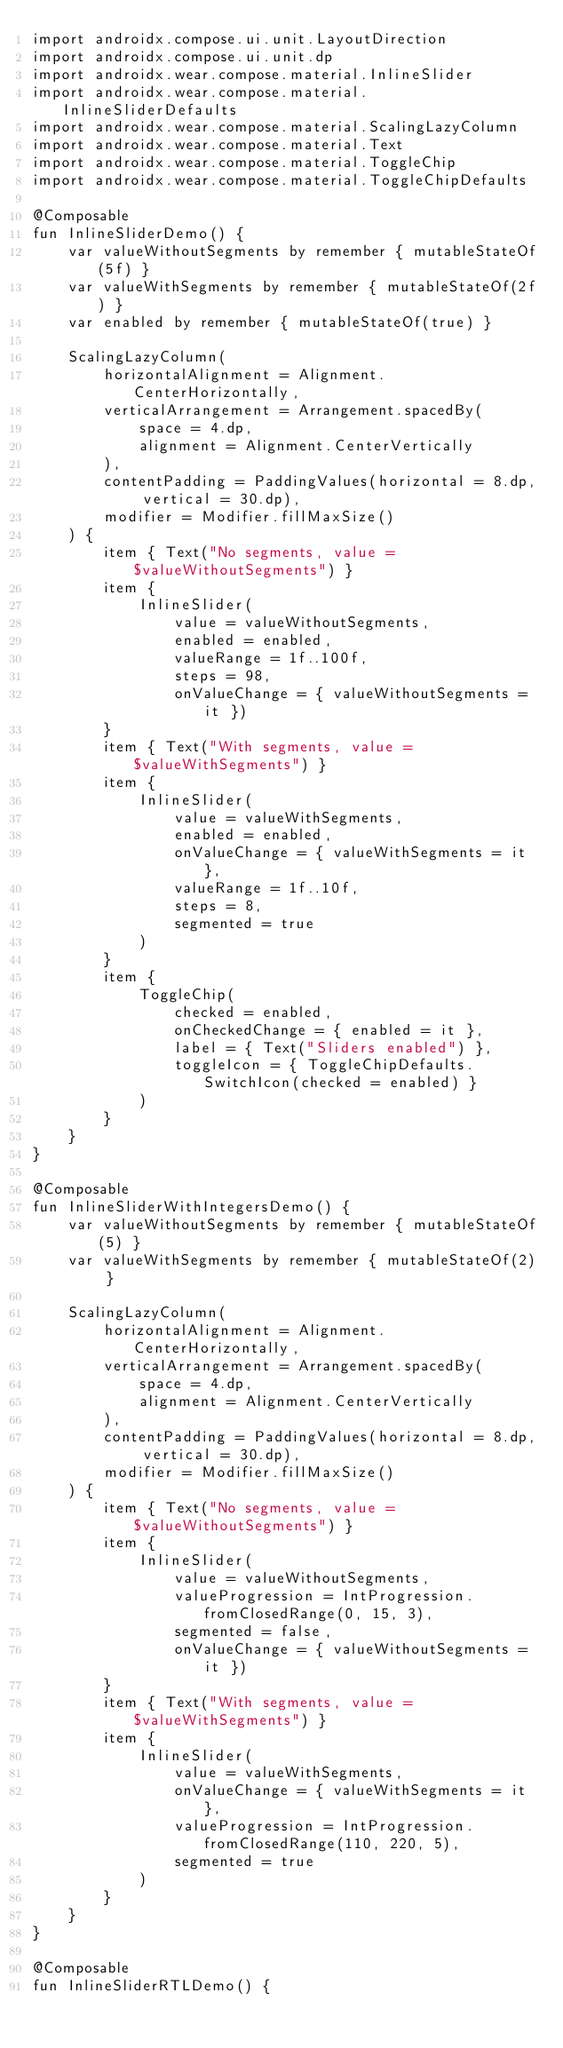Convert code to text. <code><loc_0><loc_0><loc_500><loc_500><_Kotlin_>import androidx.compose.ui.unit.LayoutDirection
import androidx.compose.ui.unit.dp
import androidx.wear.compose.material.InlineSlider
import androidx.wear.compose.material.InlineSliderDefaults
import androidx.wear.compose.material.ScalingLazyColumn
import androidx.wear.compose.material.Text
import androidx.wear.compose.material.ToggleChip
import androidx.wear.compose.material.ToggleChipDefaults

@Composable
fun InlineSliderDemo() {
    var valueWithoutSegments by remember { mutableStateOf(5f) }
    var valueWithSegments by remember { mutableStateOf(2f) }
    var enabled by remember { mutableStateOf(true) }

    ScalingLazyColumn(
        horizontalAlignment = Alignment.CenterHorizontally,
        verticalArrangement = Arrangement.spacedBy(
            space = 4.dp,
            alignment = Alignment.CenterVertically
        ),
        contentPadding = PaddingValues(horizontal = 8.dp, vertical = 30.dp),
        modifier = Modifier.fillMaxSize()
    ) {
        item { Text("No segments, value = $valueWithoutSegments") }
        item {
            InlineSlider(
                value = valueWithoutSegments,
                enabled = enabled,
                valueRange = 1f..100f,
                steps = 98,
                onValueChange = { valueWithoutSegments = it })
        }
        item { Text("With segments, value = $valueWithSegments") }
        item {
            InlineSlider(
                value = valueWithSegments,
                enabled = enabled,
                onValueChange = { valueWithSegments = it },
                valueRange = 1f..10f,
                steps = 8,
                segmented = true
            )
        }
        item {
            ToggleChip(
                checked = enabled,
                onCheckedChange = { enabled = it },
                label = { Text("Sliders enabled") },
                toggleIcon = { ToggleChipDefaults.SwitchIcon(checked = enabled) }
            )
        }
    }
}

@Composable
fun InlineSliderWithIntegersDemo() {
    var valueWithoutSegments by remember { mutableStateOf(5) }
    var valueWithSegments by remember { mutableStateOf(2) }

    ScalingLazyColumn(
        horizontalAlignment = Alignment.CenterHorizontally,
        verticalArrangement = Arrangement.spacedBy(
            space = 4.dp,
            alignment = Alignment.CenterVertically
        ),
        contentPadding = PaddingValues(horizontal = 8.dp, vertical = 30.dp),
        modifier = Modifier.fillMaxSize()
    ) {
        item { Text("No segments, value = $valueWithoutSegments") }
        item {
            InlineSlider(
                value = valueWithoutSegments,
                valueProgression = IntProgression.fromClosedRange(0, 15, 3),
                segmented = false,
                onValueChange = { valueWithoutSegments = it })
        }
        item { Text("With segments, value = $valueWithSegments") }
        item {
            InlineSlider(
                value = valueWithSegments,
                onValueChange = { valueWithSegments = it },
                valueProgression = IntProgression.fromClosedRange(110, 220, 5),
                segmented = true
            )
        }
    }
}

@Composable
fun InlineSliderRTLDemo() {</code> 